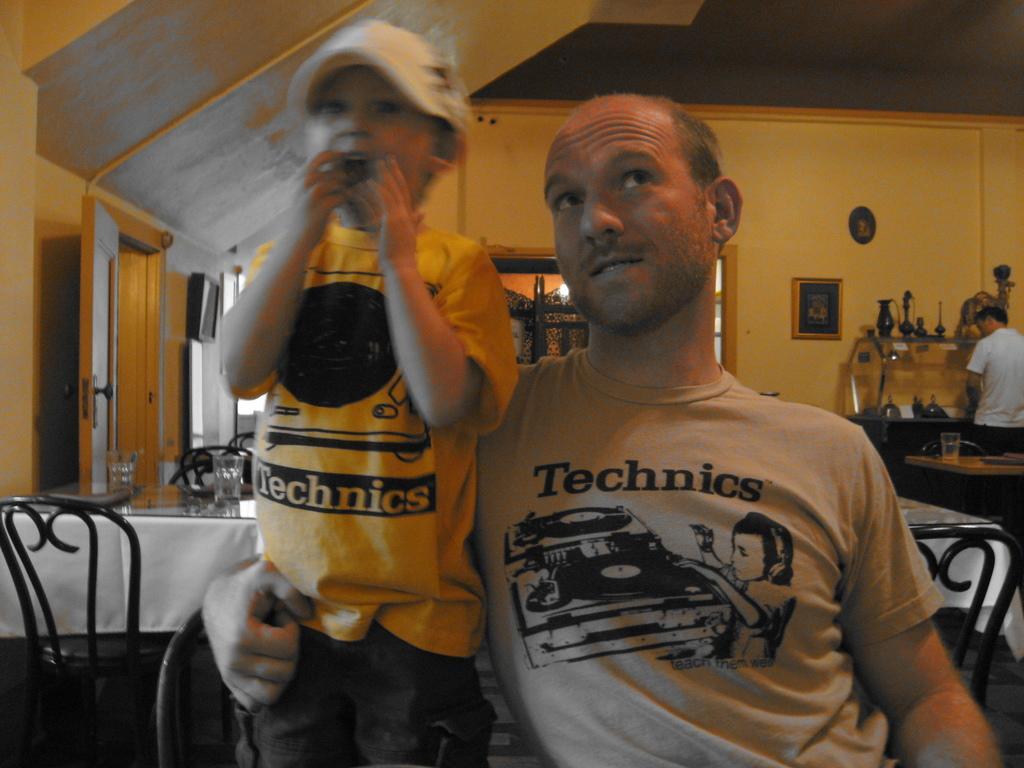Please provide a concise description of this image. As we can see in the image there is a yellow color wall, photo frame, three people over here and there are chairs and tables and on table there are glasses. 